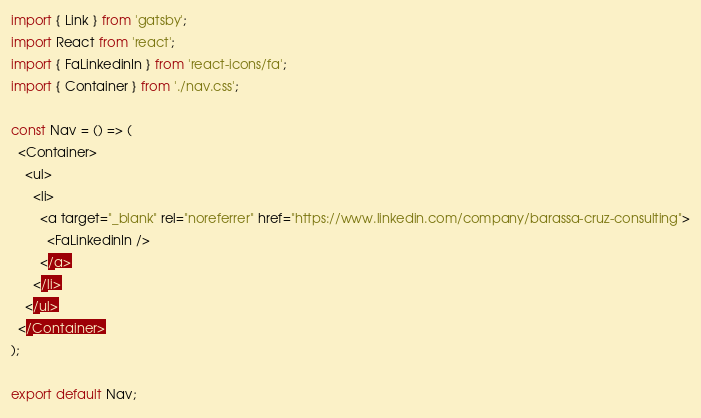Convert code to text. <code><loc_0><loc_0><loc_500><loc_500><_JavaScript_>import { Link } from 'gatsby';
import React from 'react';
import { FaLinkedinIn } from 'react-icons/fa';
import { Container } from './nav.css';

const Nav = () => (
  <Container>
    <ul>
      <li>
        <a target="_blank" rel="noreferrer" href="https://www.linkedin.com/company/barassa-cruz-consulting">
          <FaLinkedinIn />
        </a>
      </li>
    </ul>
  </Container>
);

export default Nav;
</code> 